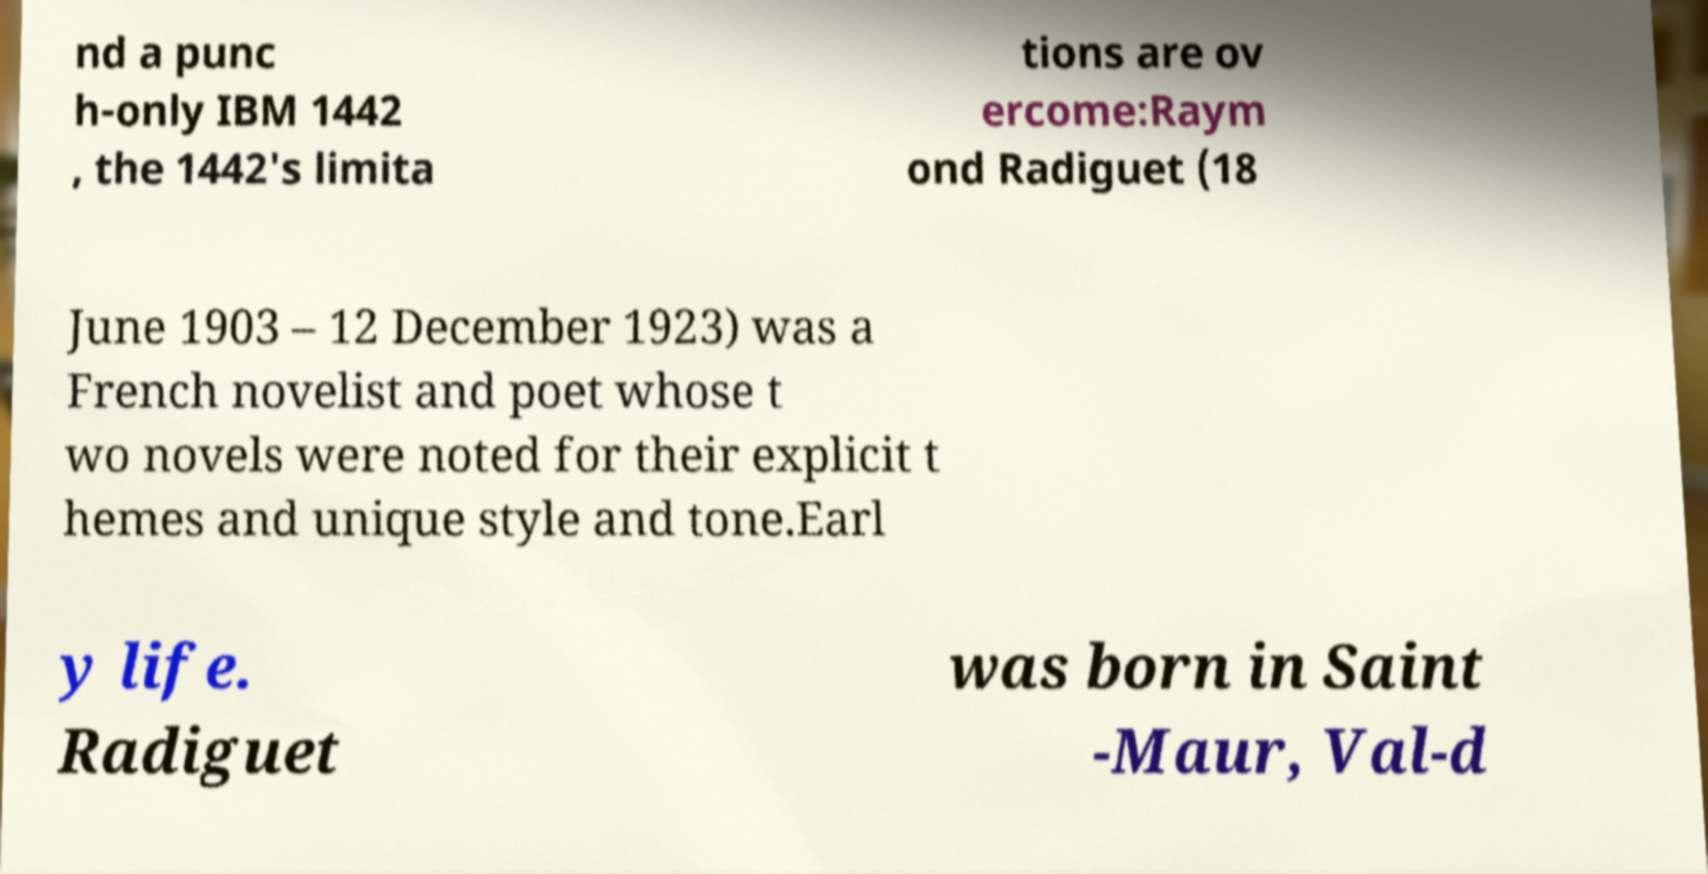For documentation purposes, I need the text within this image transcribed. Could you provide that? nd a punc h-only IBM 1442 , the 1442's limita tions are ov ercome:Raym ond Radiguet (18 June 1903 – 12 December 1923) was a French novelist and poet whose t wo novels were noted for their explicit t hemes and unique style and tone.Earl y life. Radiguet was born in Saint -Maur, Val-d 